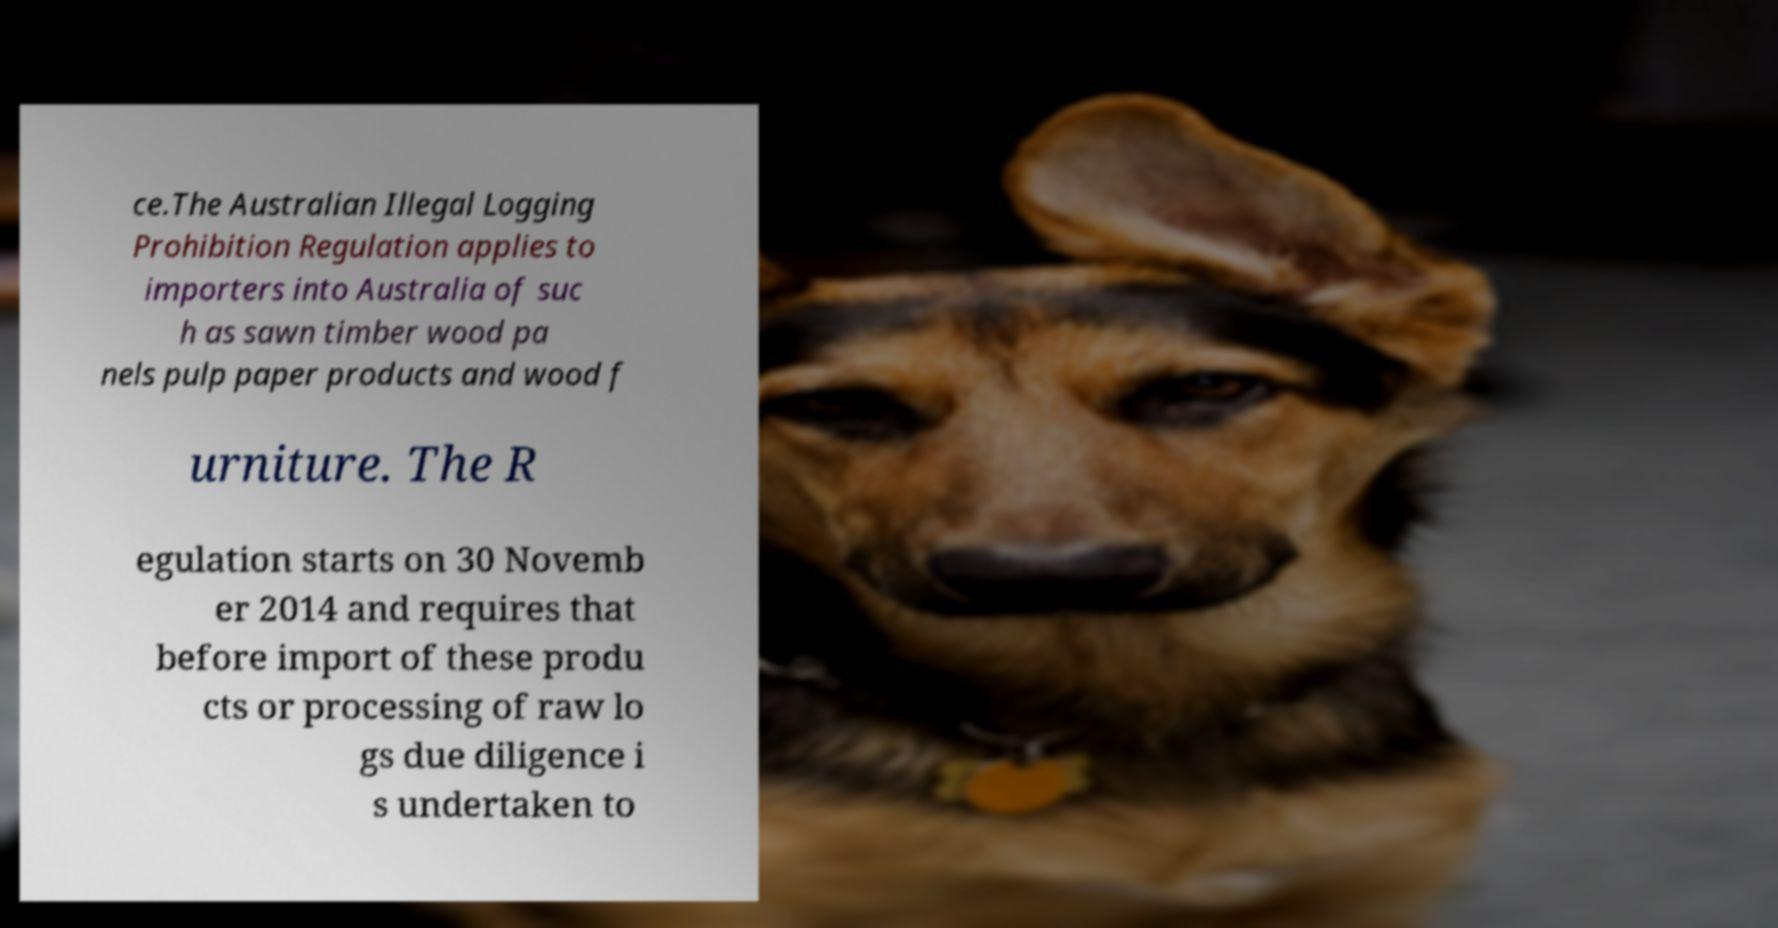There's text embedded in this image that I need extracted. Can you transcribe it verbatim? ce.The Australian Illegal Logging Prohibition Regulation applies to importers into Australia of suc h as sawn timber wood pa nels pulp paper products and wood f urniture. The R egulation starts on 30 Novemb er 2014 and requires that before import of these produ cts or processing of raw lo gs due diligence i s undertaken to 